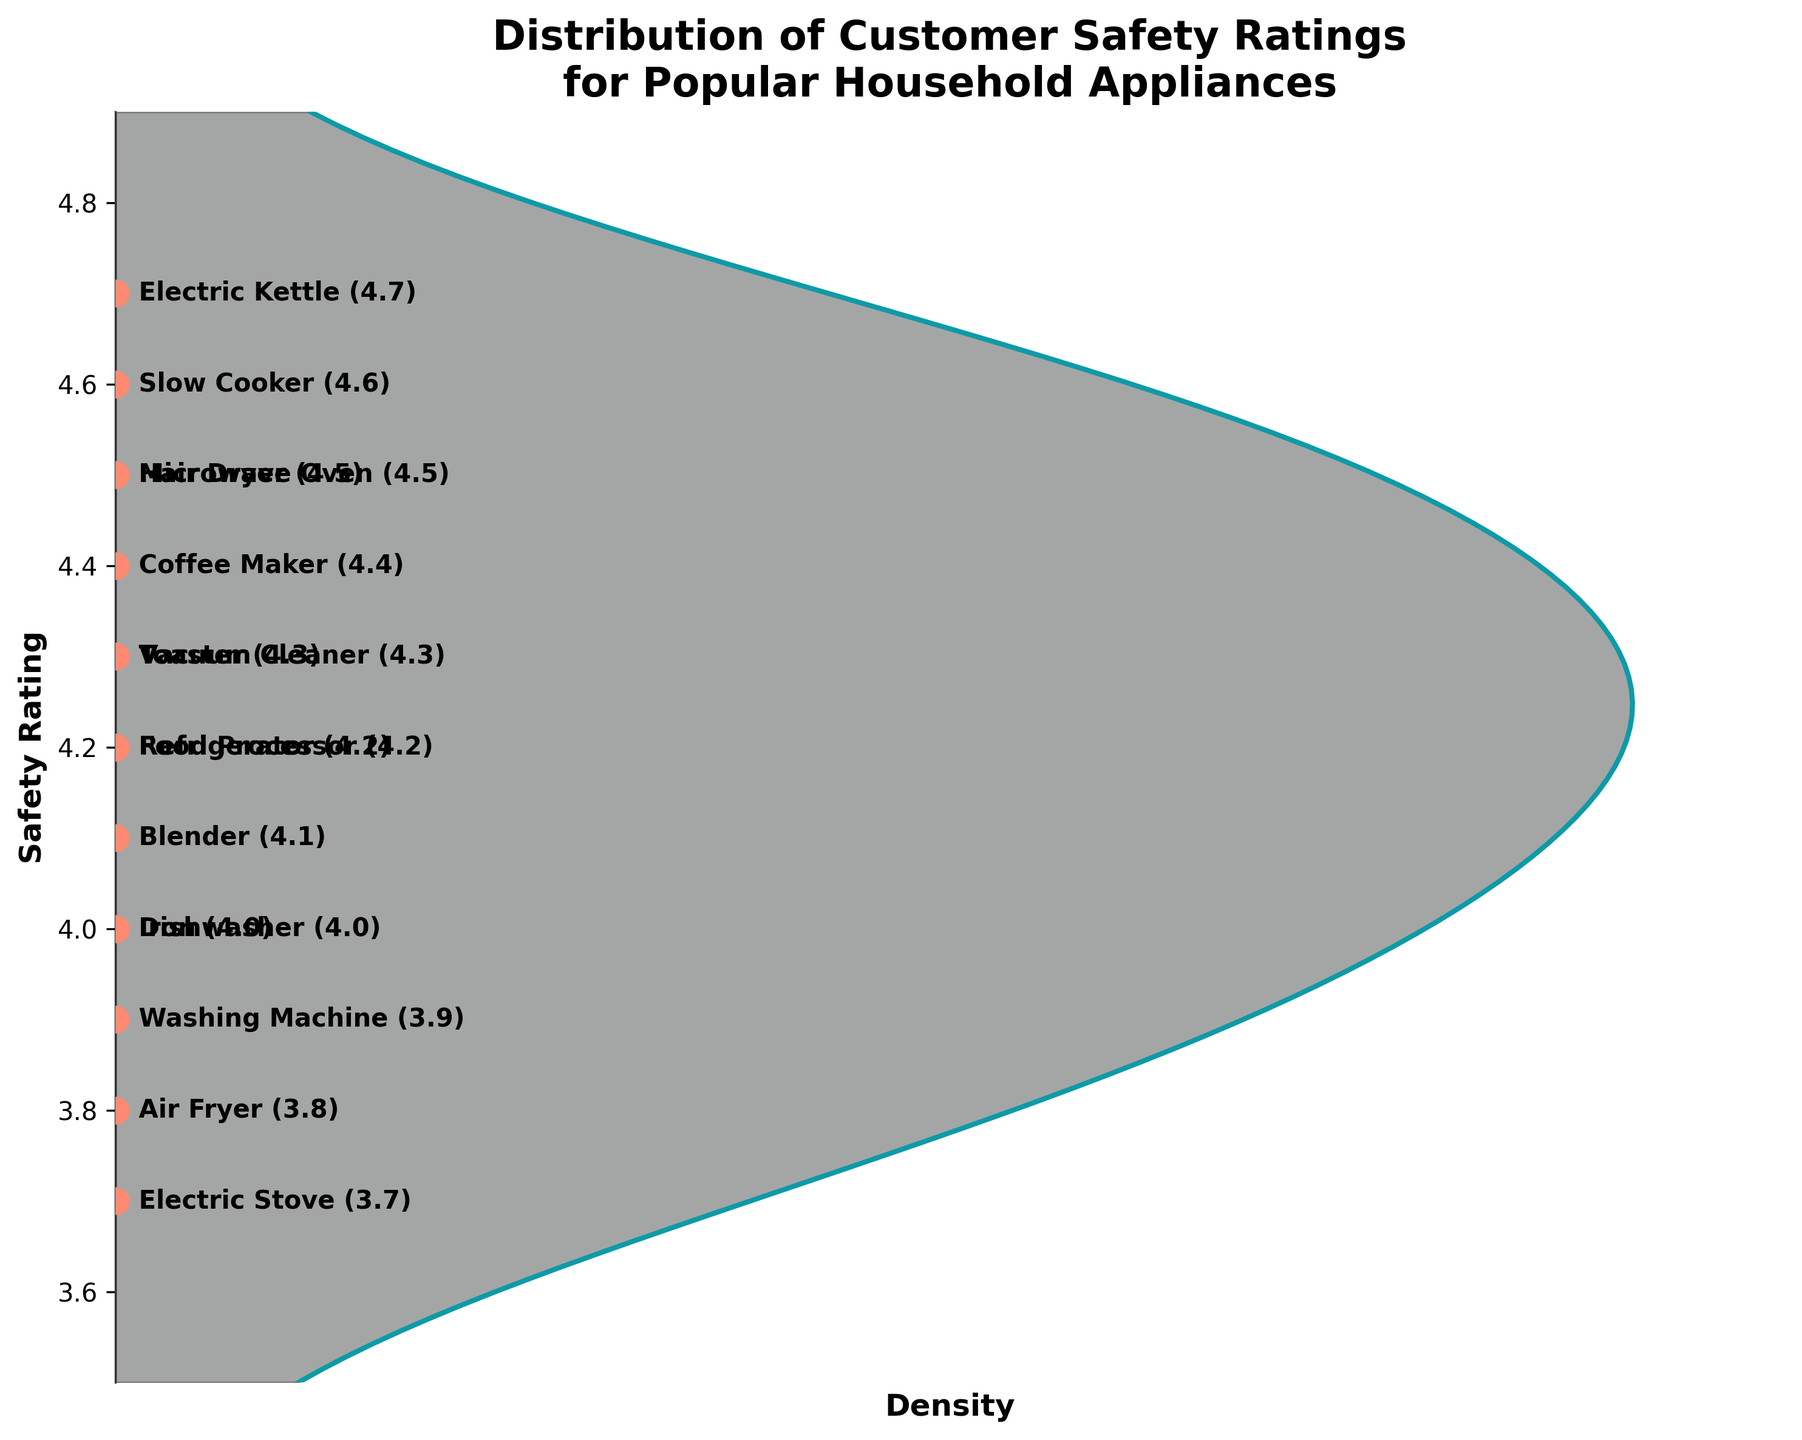Which appliance has the highest safety rating? The appliance with the highest safety rating is the one with the point at the highest position on the y-axis. In this case, the Electric Kettle has the highest rating.
Answer: Electric Kettle What is the safety rating for the Air Fryer? Look for the appliance labeled as Air Fryer and note its position on the y-axis. The Air Fryer has a safety rating of 3.8.
Answer: 3.8 How many appliances have a safety rating of 4.0 or higher? Identify all the points positioned at or above the 4.0 mark on the y-axis and count them. These are Refrigerator, Microwave Oven, Dishwasher, Electric Kettle, Toaster, Blender, Coffee Maker, Slow Cooker, Hair Dryer, Vacuum Cleaner, and Iron.
Answer: 11 Which appliance has the lowest safety rating? The appliance with the lowest safety rating is the one with the point at the lowest position on the y-axis. In this case, the Electric Stove has the lowest rating.
Answer: Electric Stove Is the safety rating for the Toaster greater or less than the safety rating for the Blender? Compare the positions of the Toaster and Blender points on the y-axis. The Toaster is rated higher (4.3) than the Blender (4.1).
Answer: Greater What is the average safety rating of all the appliances? Add up all the safety ratings and divide by the number of appliances: (4.2 + 3.9 + 4.5 + 4.0 + 4.7 + 4.3 + 4.1 + 4.4 + 3.8 + 4.6 + 4.2 + 3.7 + 4.5 + 4.3 + 4.0) / 15 = 4.2
Answer: 4.2 Which appliances have safety ratings exactly at 4.0? Identify the labels at the 4.0 mark on the y-axis. The appliances Dishwasher and Iron have safety ratings of 4.0.
Answer: Dishwasher, Iron Is there a higher density of appliances with ratings above or below 4.1? Analyze the density plot. The area above the 4.1 mark has a higher density than below 4.1, indicating more appliances with higher ratings.
Answer: Above What does the peak of the density plot indicate? The peak of the density plot represents the most common safety rating among the appliances. It shows that the most common ratings are around 4.3.
Answer: Around 4.3 Are the safety ratings of household appliances generally skewed towards higher or lower values? Examine the density distribution. Since the peak and a significant portion of the density are towards the higher end of the ratings, it indicates a skew towards higher safety ratings.
Answer: Higher 